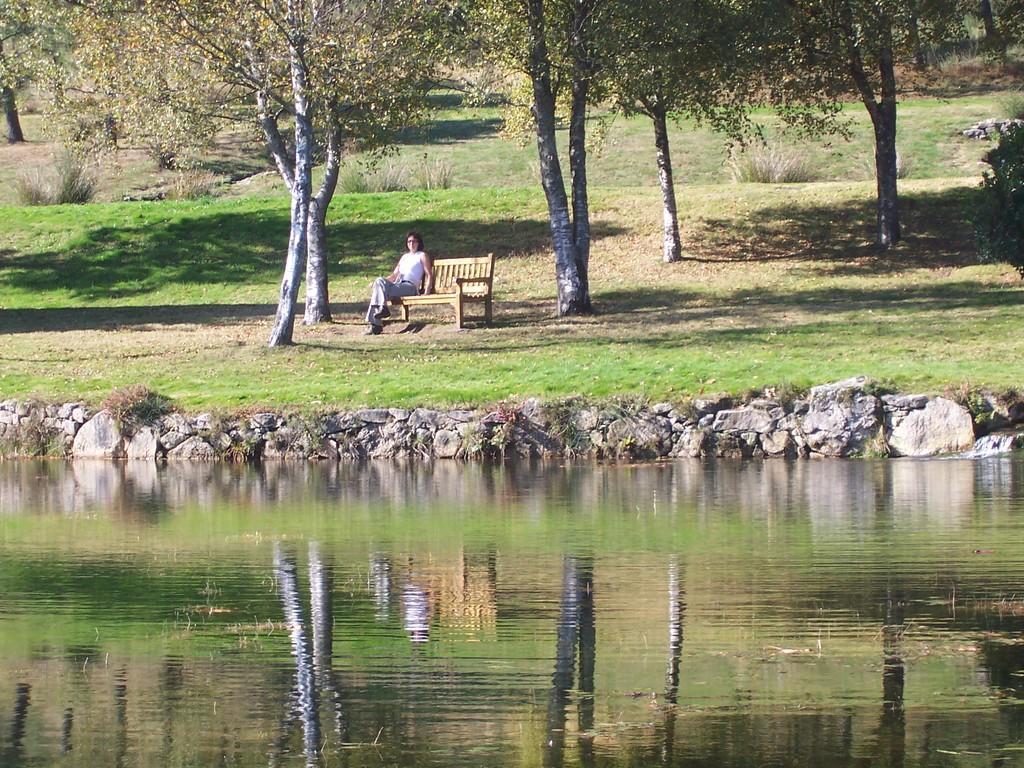What is at the bottom of the image? There is water at the bottom of the image. What can be seen in the background of the image? There are trees, plants, grass, stones, and a woman sitting on a wooden bench in the background of the image. What language is the scarecrow speaking in the image? There is no scarecrow present in the image, so it is not possible to determine what language it might be speaking. 